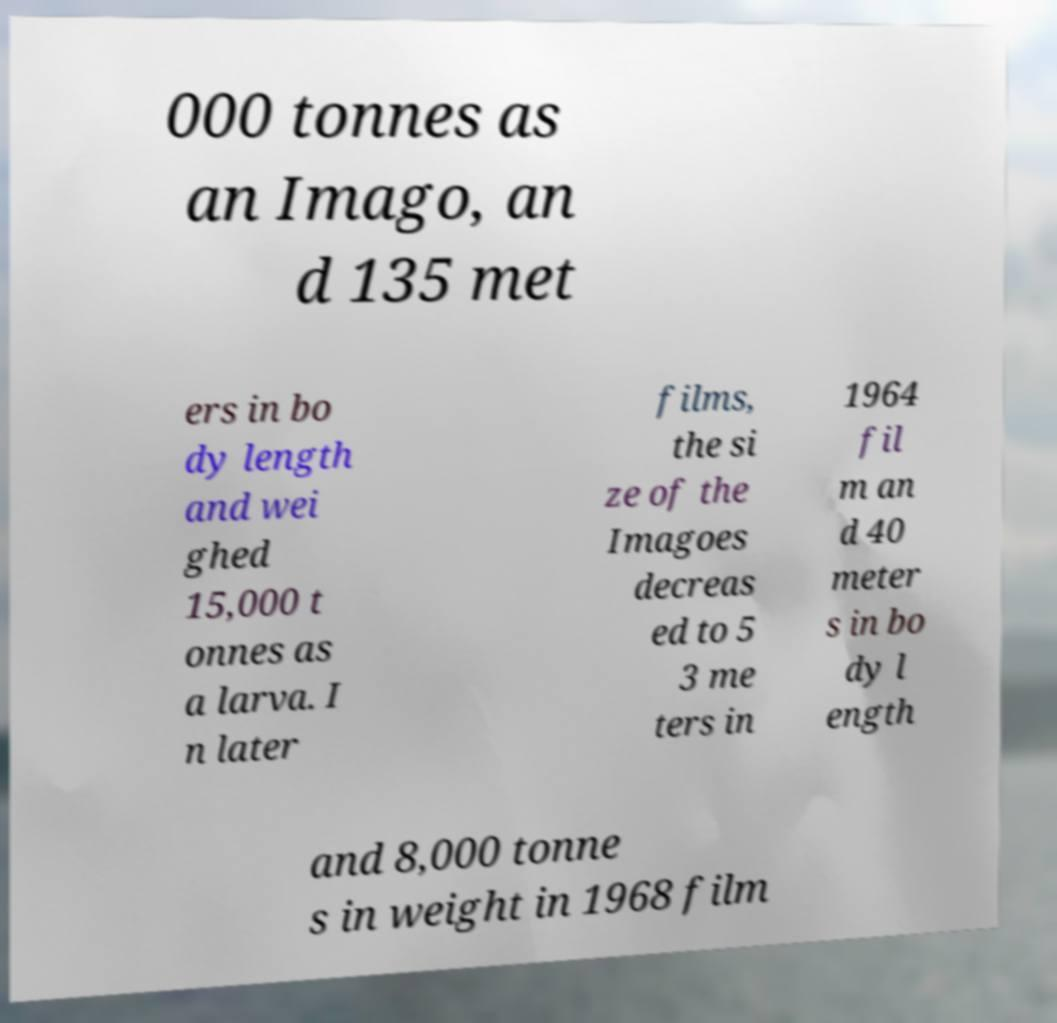I need the written content from this picture converted into text. Can you do that? 000 tonnes as an Imago, an d 135 met ers in bo dy length and wei ghed 15,000 t onnes as a larva. I n later films, the si ze of the Imagoes decreas ed to 5 3 me ters in 1964 fil m an d 40 meter s in bo dy l ength and 8,000 tonne s in weight in 1968 film 